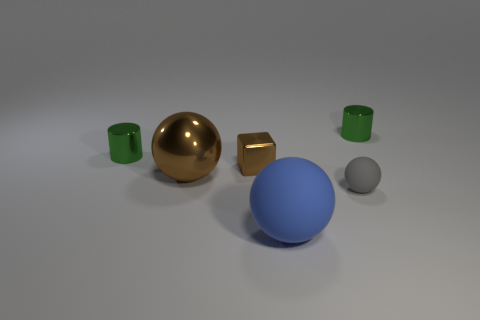Subtract all big spheres. How many spheres are left? 1 Add 2 small yellow spheres. How many objects exist? 8 Add 4 large matte things. How many large matte things are left? 5 Add 5 big things. How many big things exist? 7 Subtract 0 blue cylinders. How many objects are left? 6 Subtract all blocks. How many objects are left? 5 Subtract all tiny objects. Subtract all green things. How many objects are left? 0 